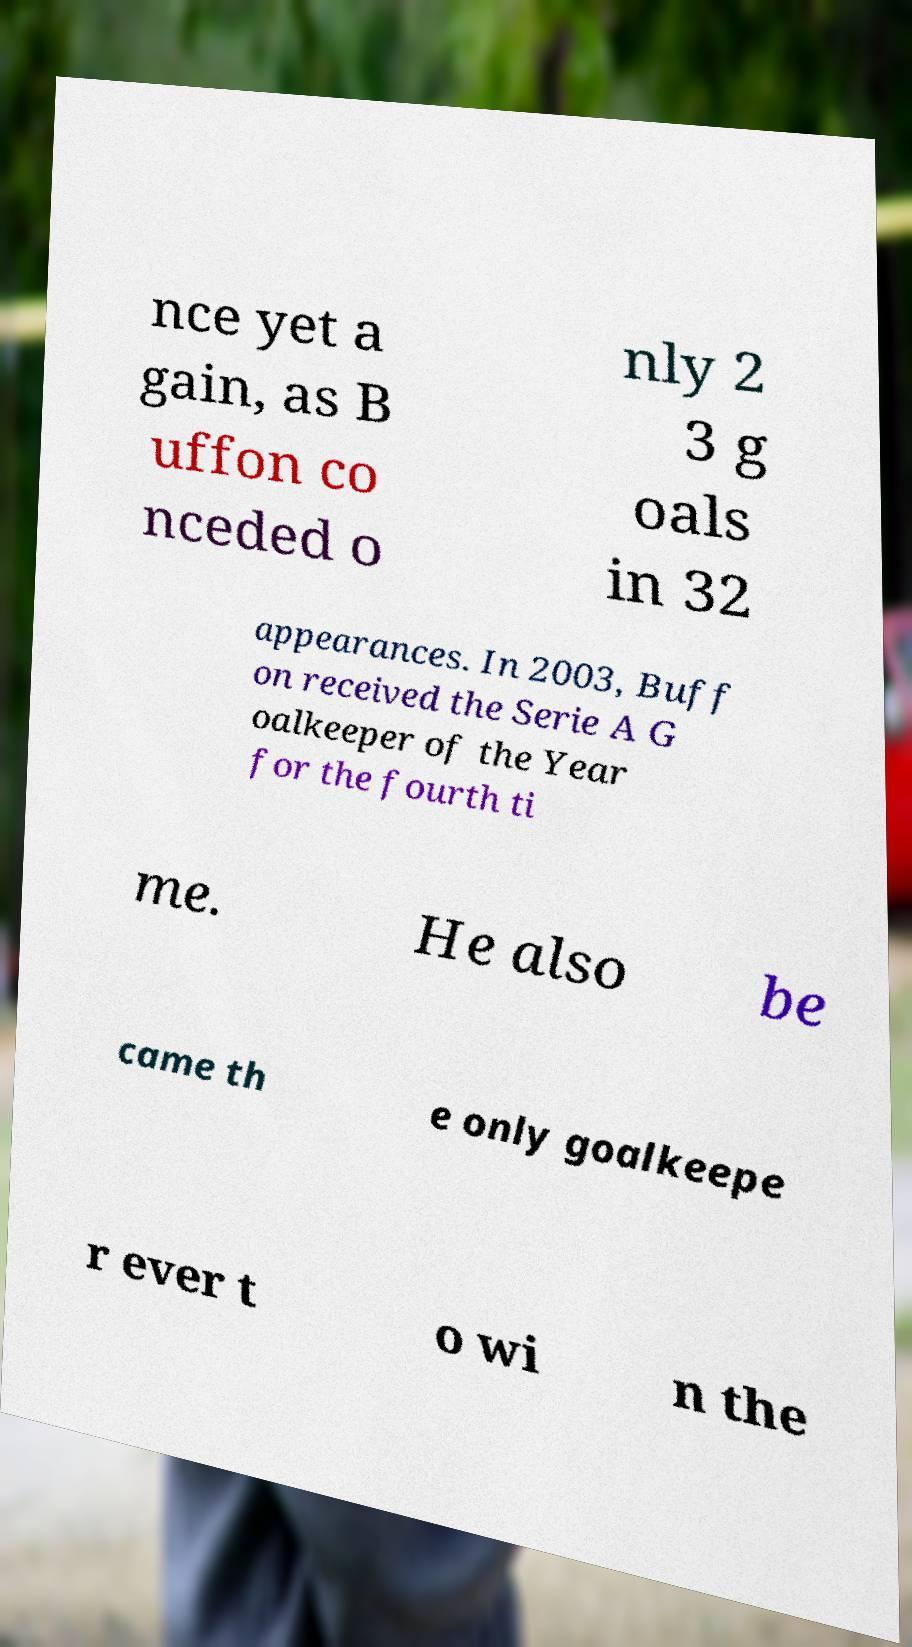Could you assist in decoding the text presented in this image and type it out clearly? nce yet a gain, as B uffon co nceded o nly 2 3 g oals in 32 appearances. In 2003, Buff on received the Serie A G oalkeeper of the Year for the fourth ti me. He also be came th e only goalkeepe r ever t o wi n the 